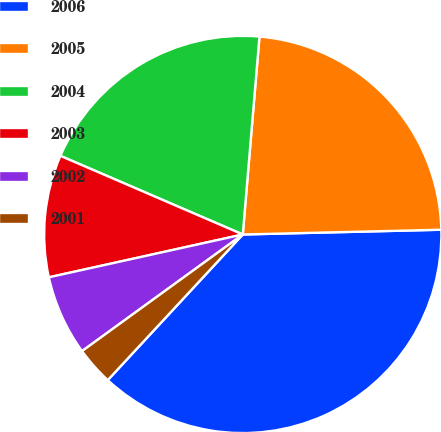Convert chart to OTSL. <chart><loc_0><loc_0><loc_500><loc_500><pie_chart><fcel>2006<fcel>2005<fcel>2004<fcel>2003<fcel>2002<fcel>2001<nl><fcel>37.28%<fcel>23.28%<fcel>19.86%<fcel>9.94%<fcel>6.53%<fcel>3.11%<nl></chart> 